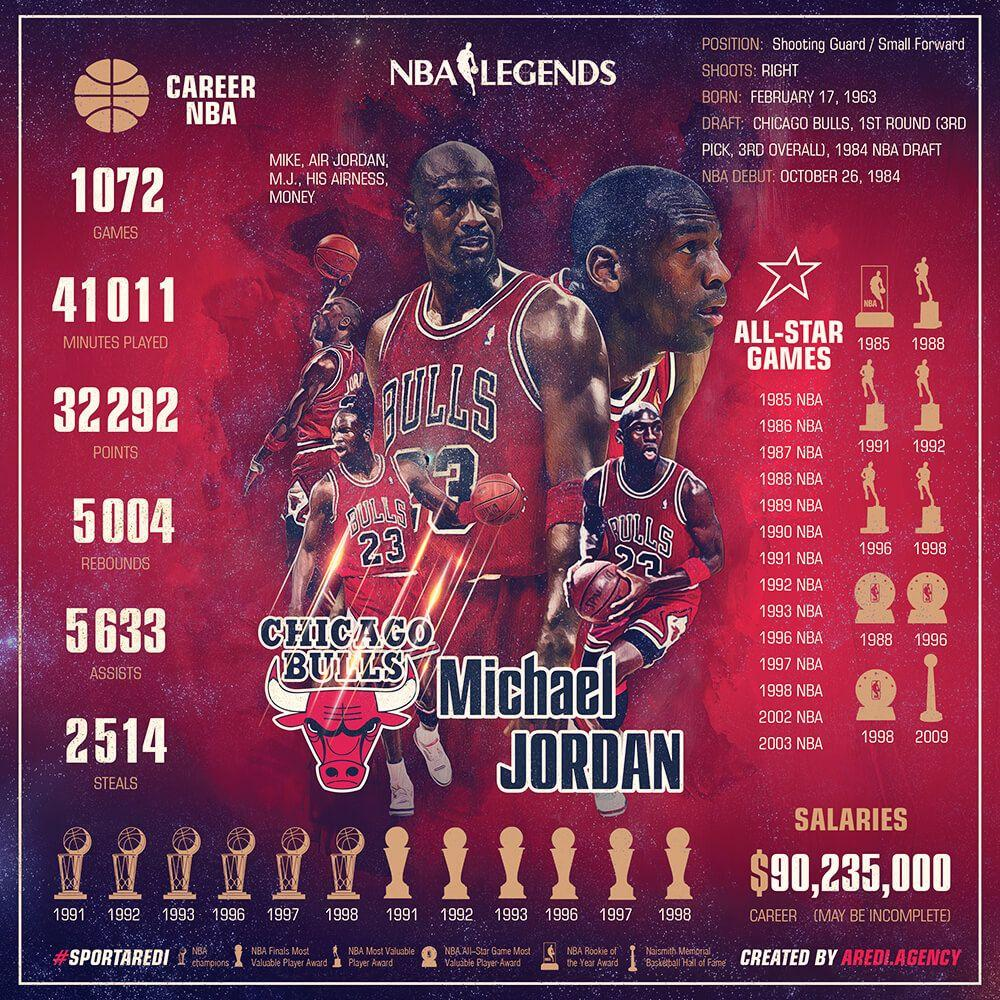Specify some key components in this picture. Michael Jordan received the NBA Most Valuable Player award a total of five times. Michael Jordan was awarded the NBA Finals Most Valuable Player Award a total of six times. Michael Jordan was awarded the NBA Champions title for a total of 6 years. Michael Jordan was awarded the NBA All-Star Game Most Valuable Player award on three occasions: in 1988, 1996, and 1998. In the year 1985, Michael Jordan received the NBA Rookie of the Year award. 